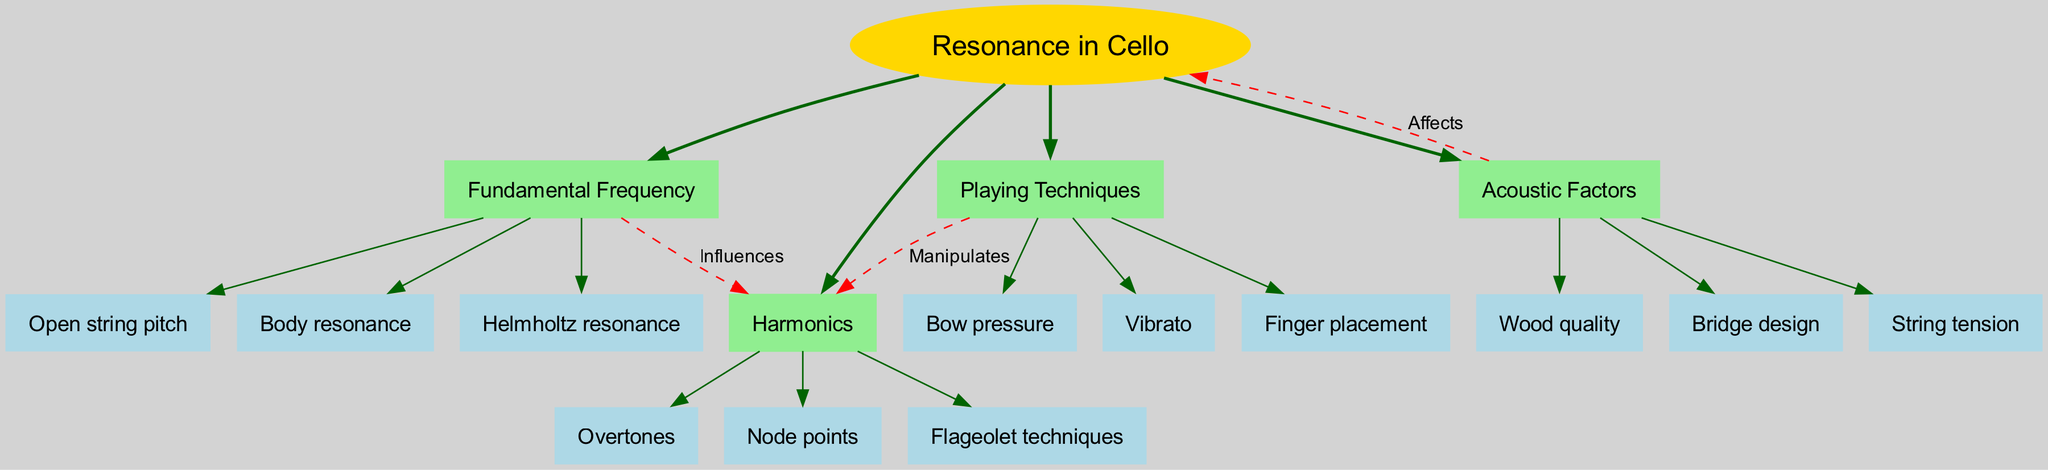What is the central topic of the diagram? The central topic node clearly states "Resonance in Cello," which is the main focus of the diagram.
Answer: Resonance in Cello How many main branches are present? Counting the nodes connected directly to the central topic shows there are four main branches: Fundamental Frequency, Harmonics, Acoustic Factors, and Playing Techniques.
Answer: 4 Which branch influences Harmonics? The diagram indicates a dashed connection from the "Fundamental Frequency" branch to the "Harmonics" branch labeled "Influences."
Answer: Fundamental Frequency Name one subbranch under Acoustic Factors. The subbranches listed under "Acoustic Factors" include "Wood quality," "Bridge design," and "String tension."
Answer: Wood quality What affects the resonance in cello according to the diagram? The connection labeled "Affects" from the "Acoustic Factors" branch to the central topic indicates what impacts resonance in cello.
Answer: Acoustic Factors What technique manipulates Harmonics? The diagram shows a direct connection from the "Playing Techniques" branch to the "Harmonics" branch labeled "Manipulates."
Answer: Playing Techniques How many subbranches does the Harmonics branch have? The "Harmonics" branch has three subbranches: Overtones, Node points, and Flageolet techniques. Counting these will give the answer.
Answer: 3 Which subbranch is specifically related to string pitch? Within the "Fundamental Frequency" branch, "Open string pitch" is specifically related to the pitch of the string.
Answer: Open string pitch Identify the connection style used between the branches and central topic. The edges connecting the main branches to the central topic are labeled as "bold," while the relationships between branches are dashed, indicating different styles.
Answer: Bold for main branches, dashed for connections 